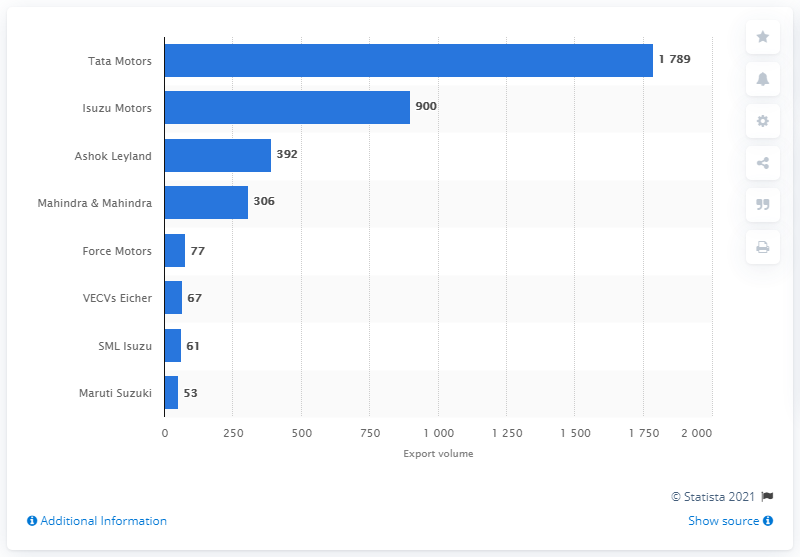Indicate a few pertinent items in this graphic. Tata Motors was the market leader in India as of March 2020. 